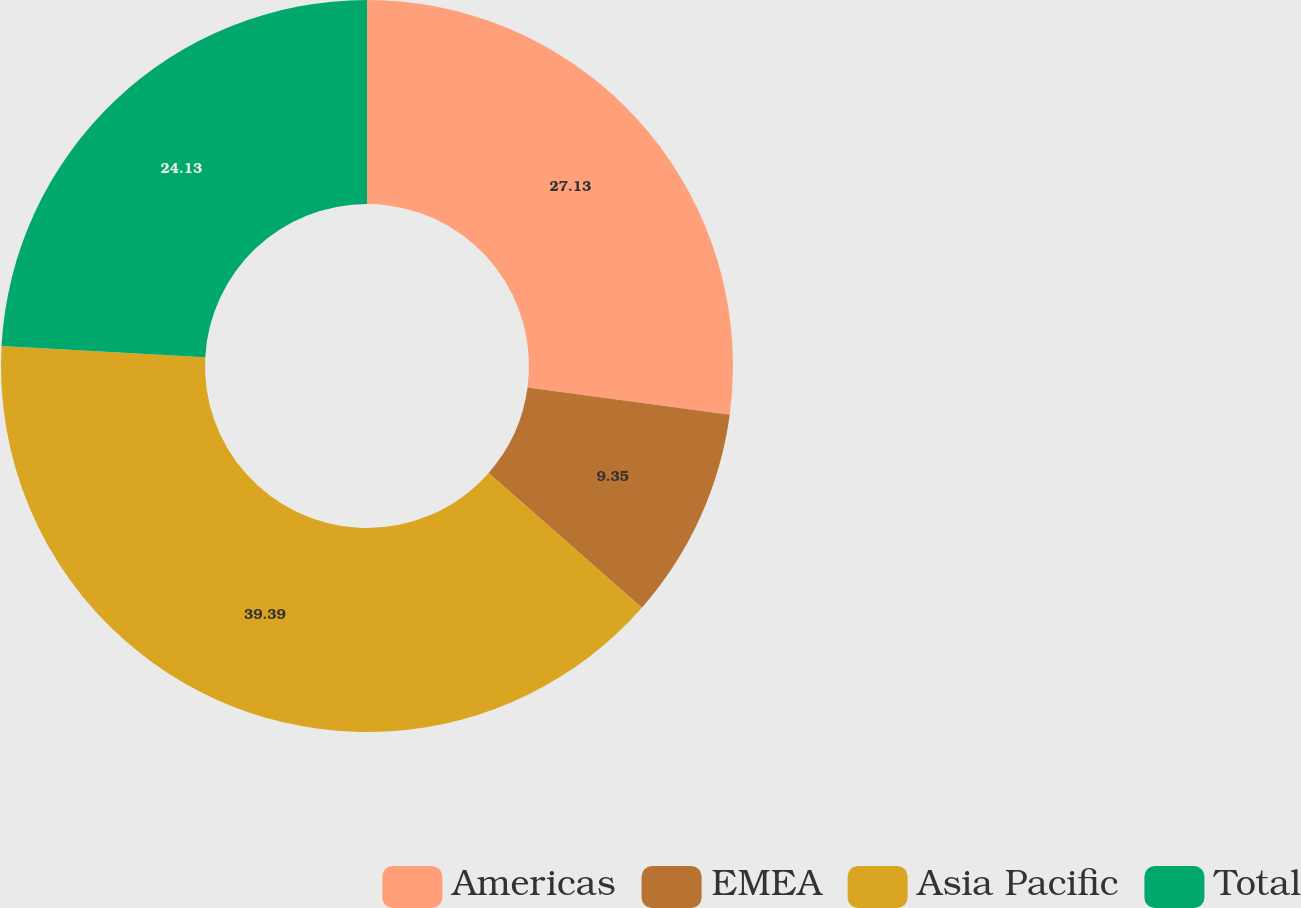Convert chart to OTSL. <chart><loc_0><loc_0><loc_500><loc_500><pie_chart><fcel>Americas<fcel>EMEA<fcel>Asia Pacific<fcel>Total<nl><fcel>27.13%<fcel>9.35%<fcel>39.39%<fcel>24.13%<nl></chart> 